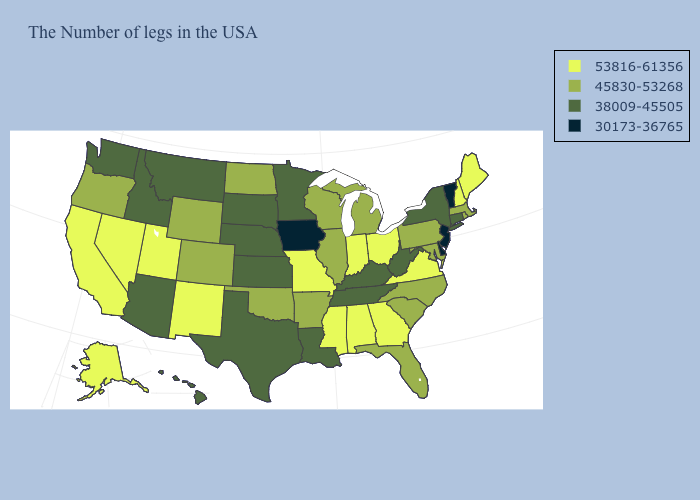What is the value of Massachusetts?
Quick response, please. 45830-53268. Among the states that border Utah , does Arizona have the lowest value?
Short answer required. Yes. Does New Jersey have the lowest value in the Northeast?
Write a very short answer. Yes. What is the highest value in states that border Delaware?
Be succinct. 45830-53268. Does South Carolina have the highest value in the South?
Give a very brief answer. No. What is the value of Wyoming?
Quick response, please. 45830-53268. Name the states that have a value in the range 45830-53268?
Give a very brief answer. Massachusetts, Rhode Island, Maryland, Pennsylvania, North Carolina, South Carolina, Florida, Michigan, Wisconsin, Illinois, Arkansas, Oklahoma, North Dakota, Wyoming, Colorado, Oregon. Name the states that have a value in the range 45830-53268?
Concise answer only. Massachusetts, Rhode Island, Maryland, Pennsylvania, North Carolina, South Carolina, Florida, Michigan, Wisconsin, Illinois, Arkansas, Oklahoma, North Dakota, Wyoming, Colorado, Oregon. What is the value of Louisiana?
Answer briefly. 38009-45505. What is the value of Florida?
Write a very short answer. 45830-53268. What is the value of Massachusetts?
Concise answer only. 45830-53268. What is the value of Utah?
Write a very short answer. 53816-61356. Does Utah have a higher value than New Jersey?
Short answer required. Yes. What is the lowest value in the South?
Write a very short answer. 30173-36765. Does Kentucky have a higher value than Idaho?
Short answer required. No. 